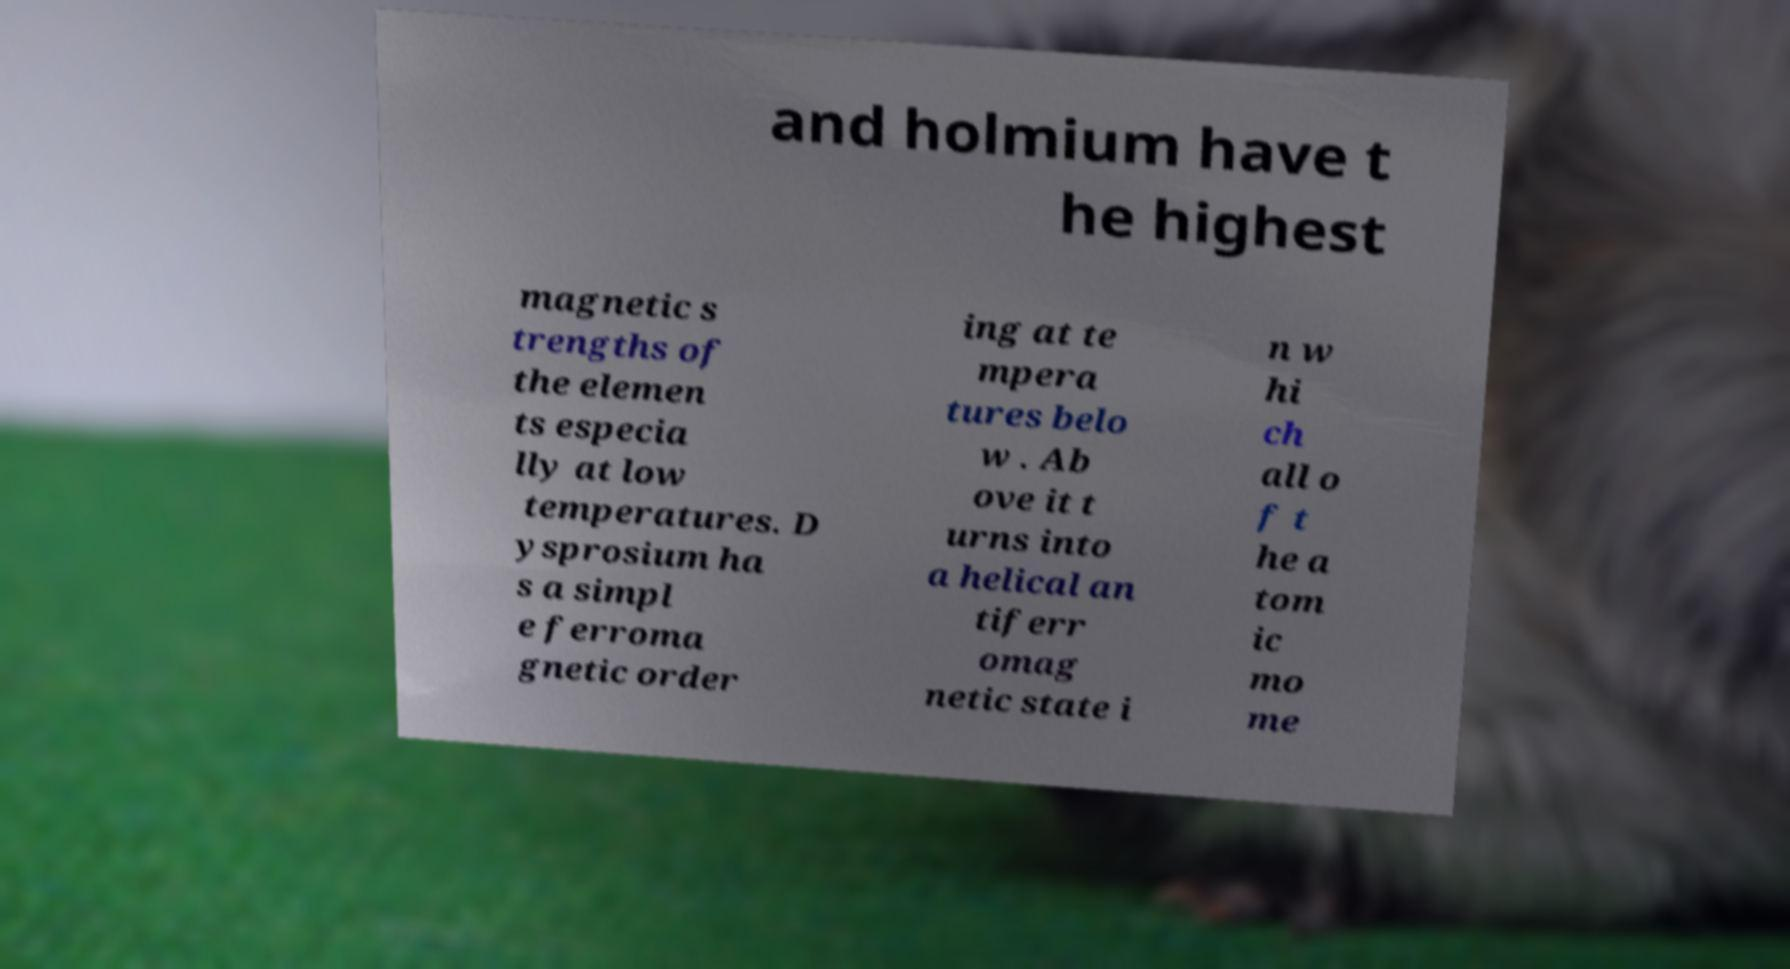I need the written content from this picture converted into text. Can you do that? and holmium have t he highest magnetic s trengths of the elemen ts especia lly at low temperatures. D ysprosium ha s a simpl e ferroma gnetic order ing at te mpera tures belo w . Ab ove it t urns into a helical an tiferr omag netic state i n w hi ch all o f t he a tom ic mo me 